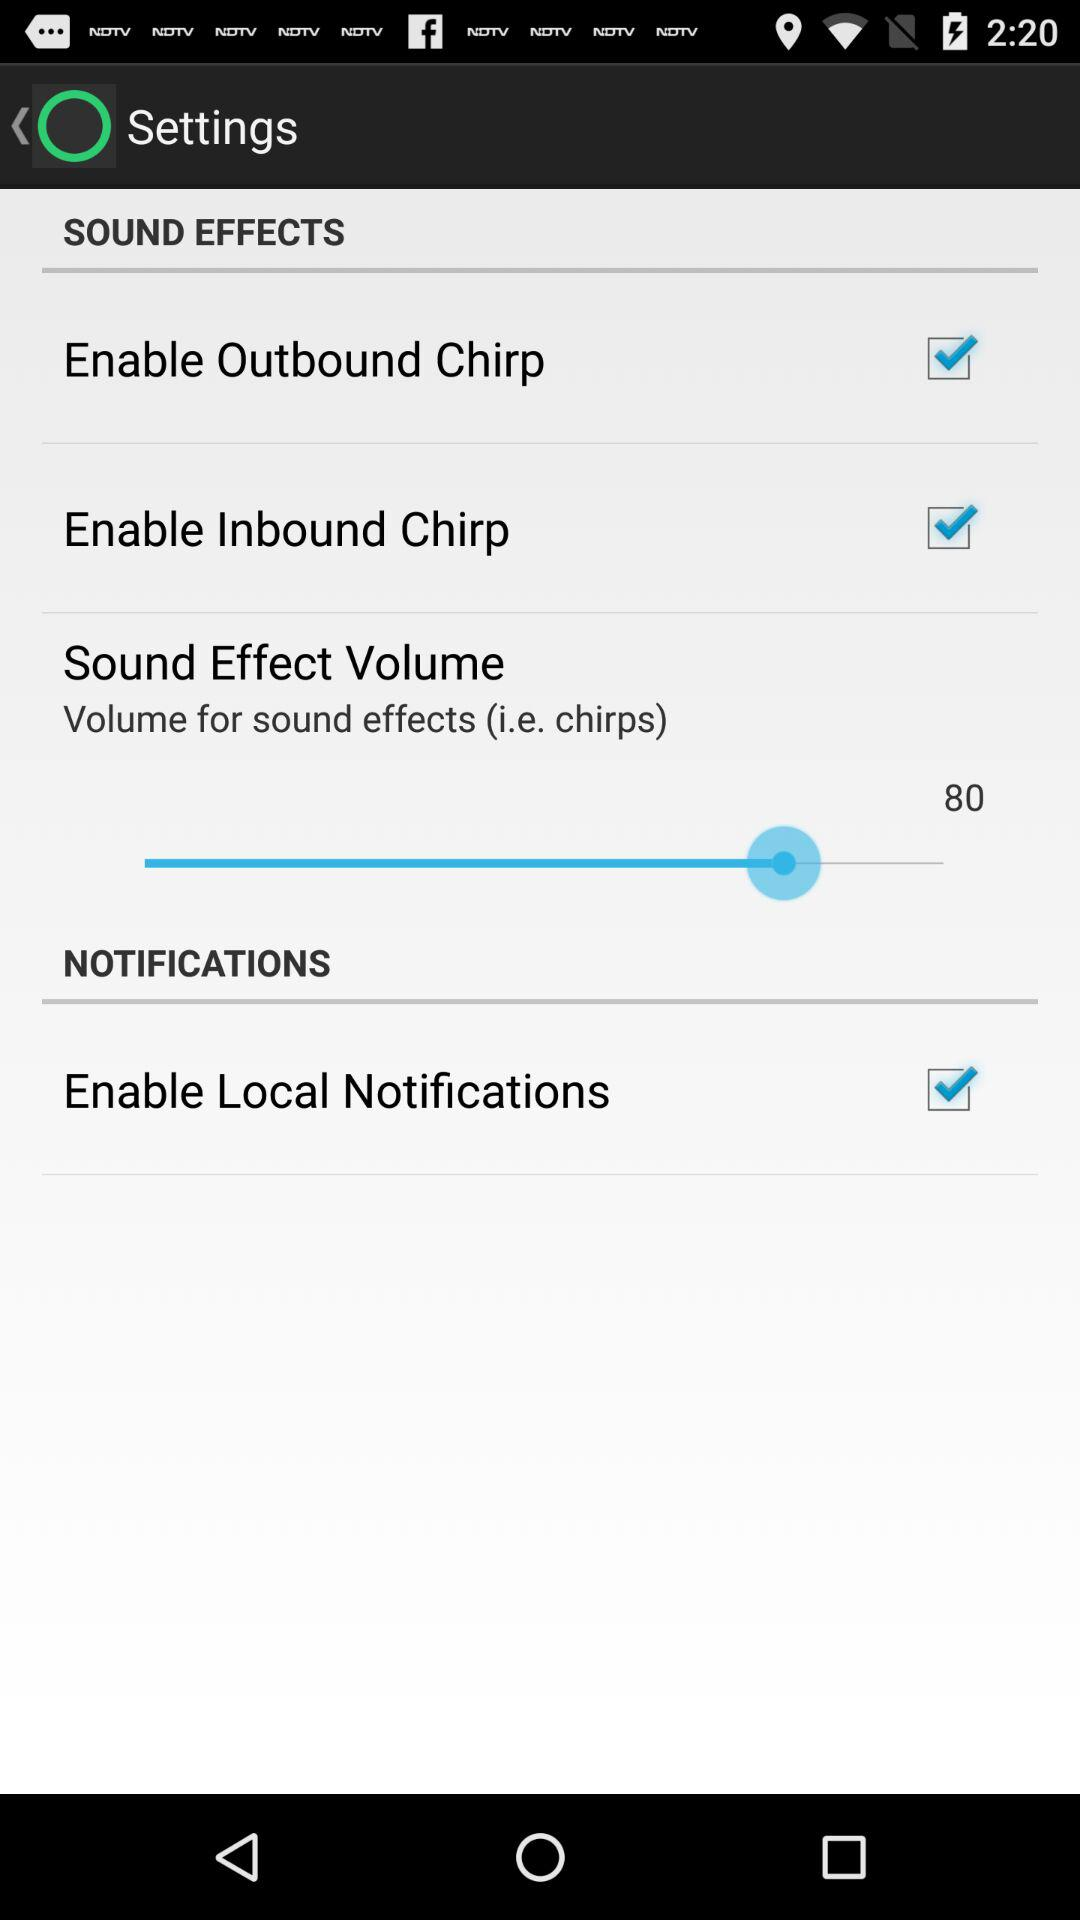How many items are in the Sound Effects section?
Answer the question using a single word or phrase. 3 